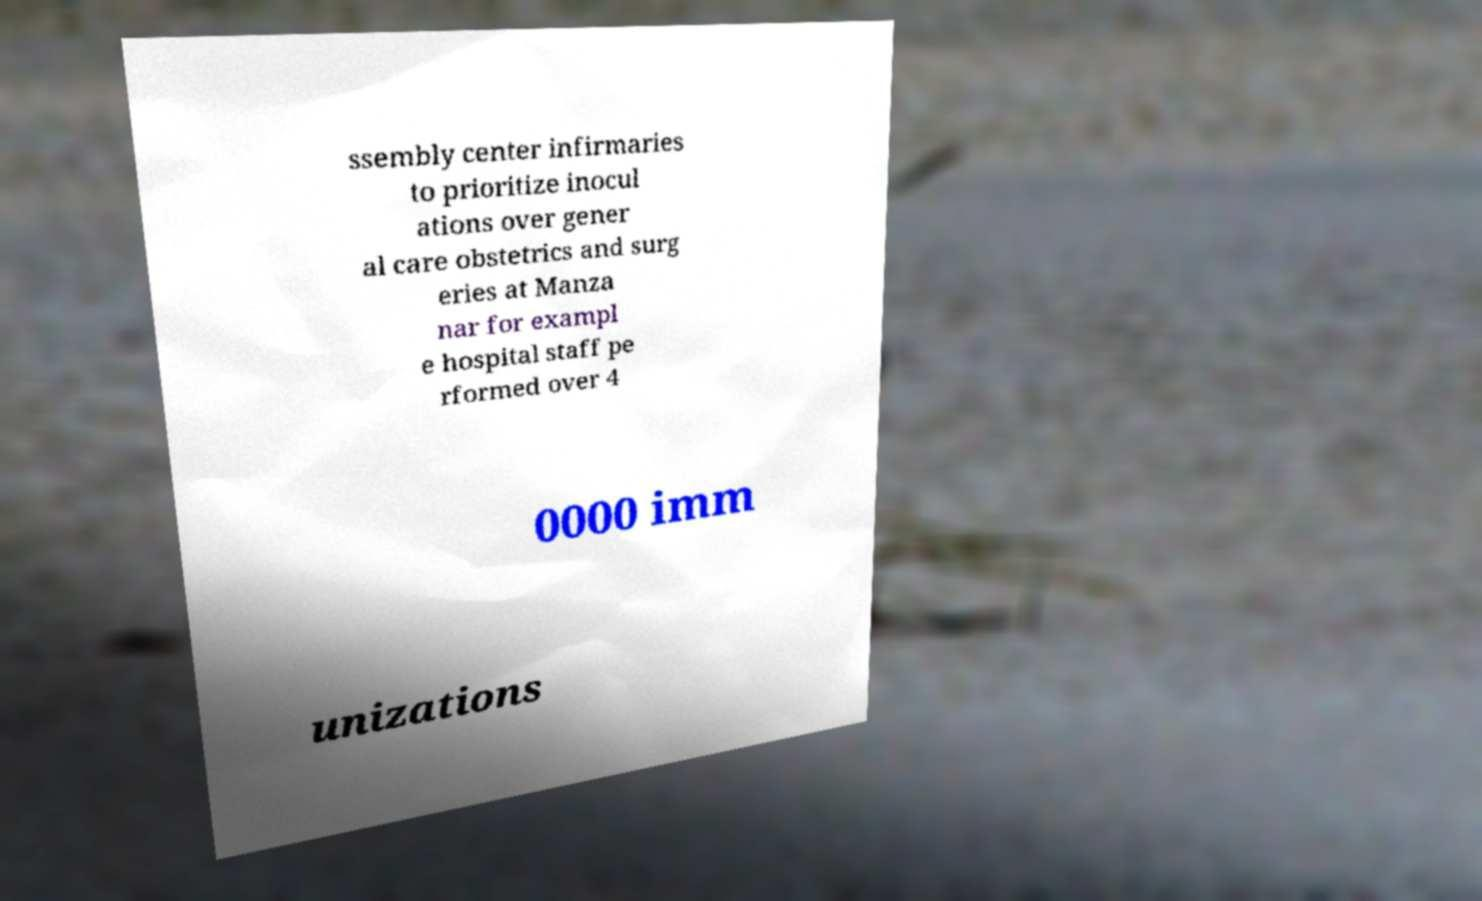For documentation purposes, I need the text within this image transcribed. Could you provide that? ssembly center infirmaries to prioritize inocul ations over gener al care obstetrics and surg eries at Manza nar for exampl e hospital staff pe rformed over 4 0000 imm unizations 